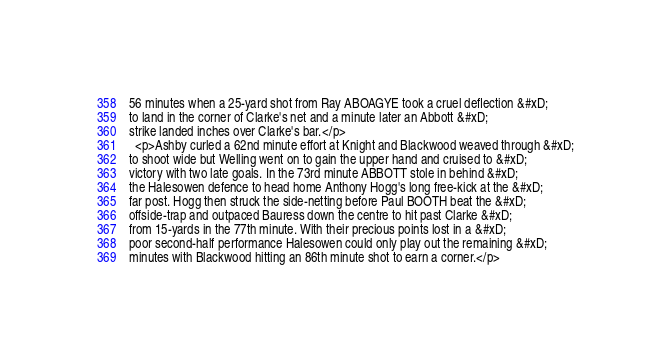<code> <loc_0><loc_0><loc_500><loc_500><_HTML_>56 minutes when a 25-yard shot from Ray ABOAGYE took a cruel deflection &#xD;
to land in the corner of Clarke's net and a minute later an Abbott &#xD;
strike landed inches over Clarke's bar.</p>
  <p>Ashby curled a 62nd minute effort at Knight and Blackwood weaved through &#xD;
to shoot wide but Welling went on to gain the upper hand and cruised to &#xD;
victory with two late goals. In the 73rd minute ABBOTT stole in behind &#xD;
the Halesowen defence to head home Anthony Hogg's long free-kick at the &#xD;
far post. Hogg then struck the side-netting before Paul BOOTH beat the &#xD;
offside-trap and outpaced Bauress down the centre to hit past Clarke &#xD;
from 15-yards in the 77th minute. With their precious points lost in a &#xD;
poor second-half performance Halesowen could only play out the remaining &#xD;
minutes with Blackwood hitting an 86th minute shot to earn a corner.</p>

</code> 